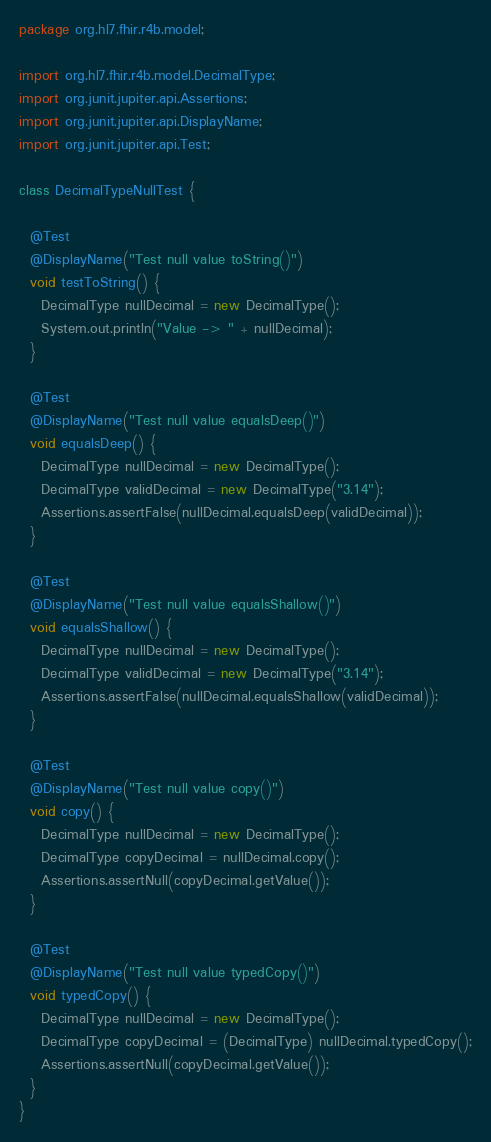<code> <loc_0><loc_0><loc_500><loc_500><_Java_>package org.hl7.fhir.r4b.model;

import org.hl7.fhir.r4b.model.DecimalType;
import org.junit.jupiter.api.Assertions;
import org.junit.jupiter.api.DisplayName;
import org.junit.jupiter.api.Test;

class DecimalTypeNullTest {

  @Test
  @DisplayName("Test null value toString()")
  void testToString() {
    DecimalType nullDecimal = new DecimalType();
    System.out.println("Value -> " + nullDecimal);
  }

  @Test
  @DisplayName("Test null value equalsDeep()")
  void equalsDeep() {
    DecimalType nullDecimal = new DecimalType();
    DecimalType validDecimal = new DecimalType("3.14");
    Assertions.assertFalse(nullDecimal.equalsDeep(validDecimal));
  }

  @Test
  @DisplayName("Test null value equalsShallow()")
  void equalsShallow() {
    DecimalType nullDecimal = new DecimalType();
    DecimalType validDecimal = new DecimalType("3.14");
    Assertions.assertFalse(nullDecimal.equalsShallow(validDecimal));
  }

  @Test
  @DisplayName("Test null value copy()")
  void copy() {
    DecimalType nullDecimal = new DecimalType();
    DecimalType copyDecimal = nullDecimal.copy();
    Assertions.assertNull(copyDecimal.getValue());
  }

  @Test
  @DisplayName("Test null value typedCopy()")
  void typedCopy() {
    DecimalType nullDecimal = new DecimalType();
    DecimalType copyDecimal = (DecimalType) nullDecimal.typedCopy();
    Assertions.assertNull(copyDecimal.getValue());
  }
}</code> 